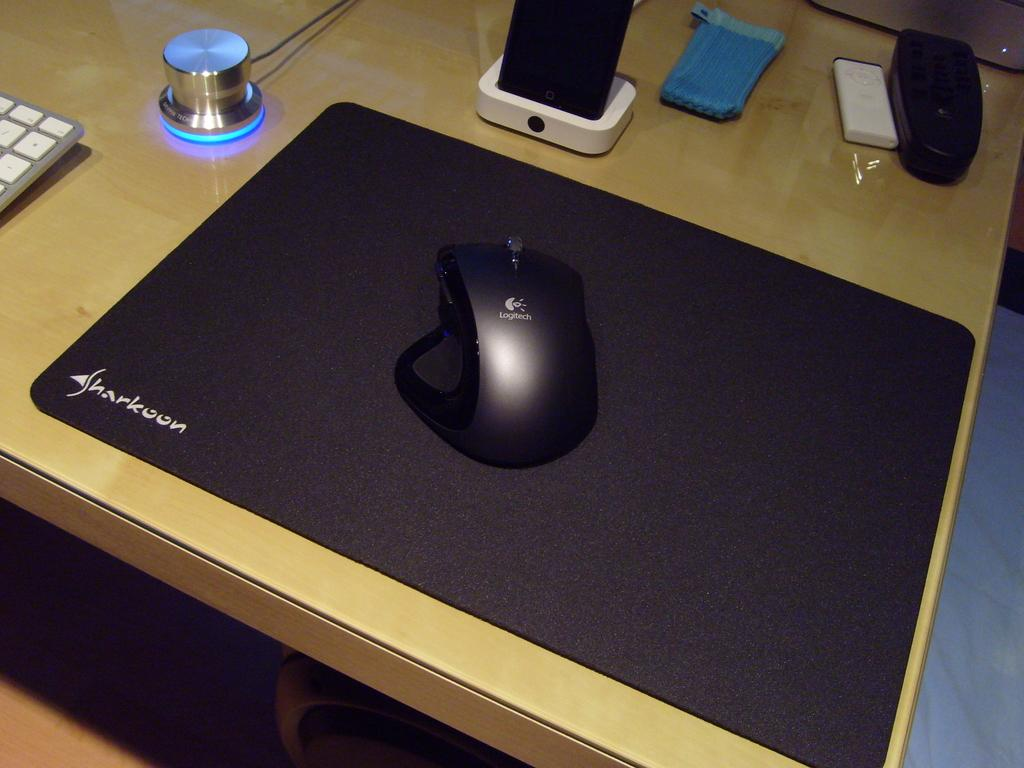What type of table is in the image? There is a wooden table in the image. What is on top of the table? There is a mouse, a keyboard, a mouse pad, a speaker, and some other objects on the table. What colors are the objects on the table? There are objects in white color and blue color on the table. What texture can be felt on the scale in the image? There is no scale present in the image. 